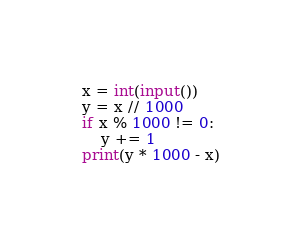Convert code to text. <code><loc_0><loc_0><loc_500><loc_500><_Python_>x = int(input())
y = x // 1000
if x % 1000 != 0:
    y += 1
print(y * 1000 - x)</code> 